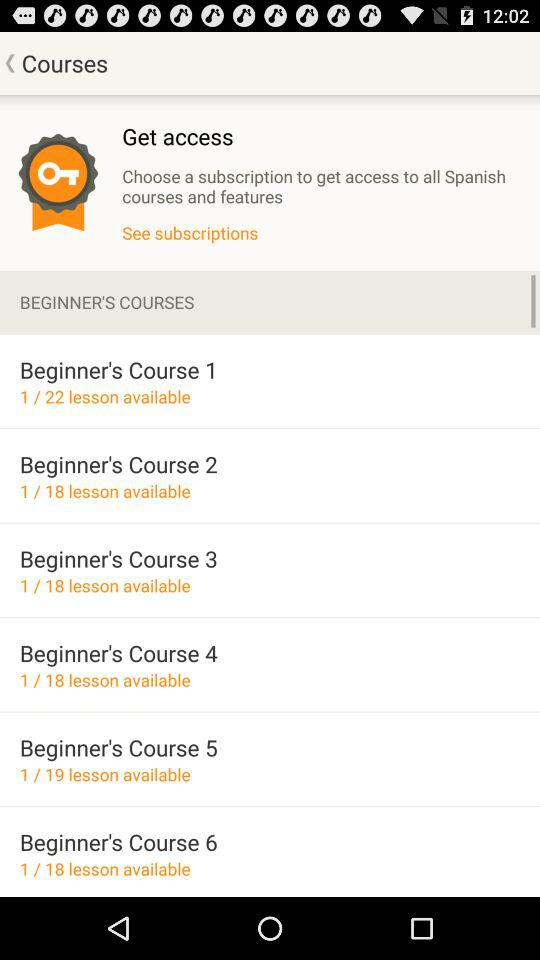What number of lessons are available in Beginner's Course 1? There are 22 lessons available in Beginner's Course 1. 